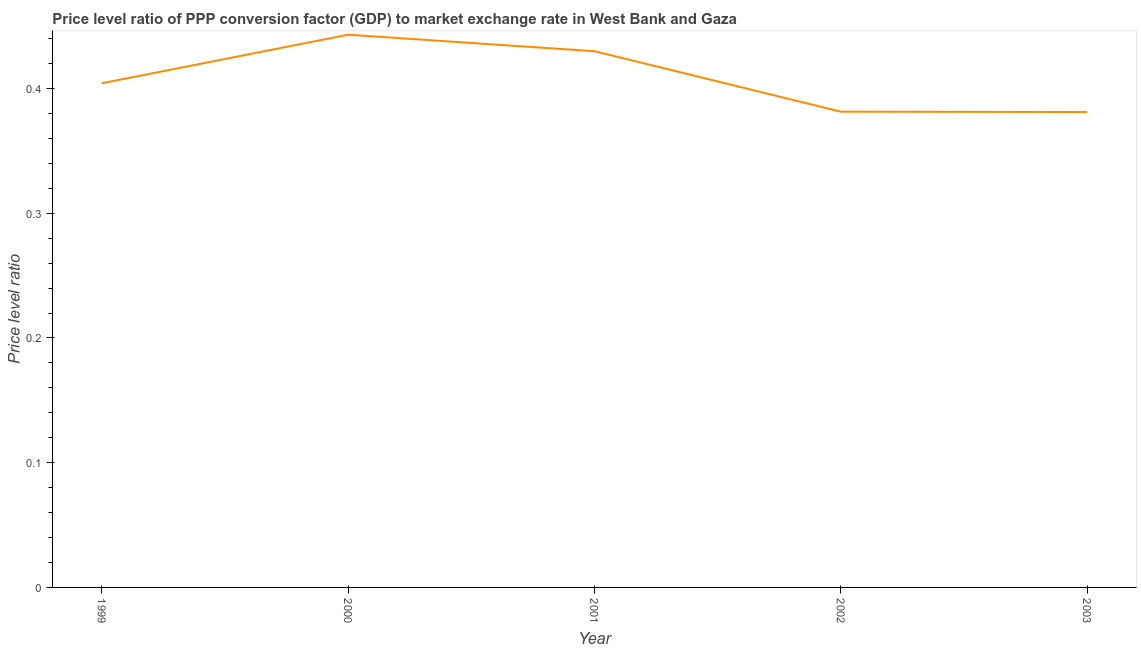What is the price level ratio in 2001?
Make the answer very short. 0.43. Across all years, what is the maximum price level ratio?
Provide a short and direct response. 0.44. Across all years, what is the minimum price level ratio?
Offer a terse response. 0.38. What is the sum of the price level ratio?
Offer a terse response. 2.04. What is the difference between the price level ratio in 2000 and 2003?
Give a very brief answer. 0.06. What is the average price level ratio per year?
Provide a succinct answer. 0.41. What is the median price level ratio?
Your response must be concise. 0.4. Do a majority of the years between 1999 and 2002 (inclusive) have price level ratio greater than 0.14 ?
Your response must be concise. Yes. What is the ratio of the price level ratio in 2000 to that in 2001?
Offer a very short reply. 1.03. What is the difference between the highest and the second highest price level ratio?
Provide a short and direct response. 0.01. Is the sum of the price level ratio in 1999 and 2001 greater than the maximum price level ratio across all years?
Make the answer very short. Yes. What is the difference between the highest and the lowest price level ratio?
Give a very brief answer. 0.06. What is the difference between two consecutive major ticks on the Y-axis?
Make the answer very short. 0.1. Are the values on the major ticks of Y-axis written in scientific E-notation?
Provide a succinct answer. No. What is the title of the graph?
Your response must be concise. Price level ratio of PPP conversion factor (GDP) to market exchange rate in West Bank and Gaza. What is the label or title of the Y-axis?
Offer a terse response. Price level ratio. What is the Price level ratio of 1999?
Your answer should be compact. 0.4. What is the Price level ratio of 2000?
Keep it short and to the point. 0.44. What is the Price level ratio in 2001?
Your answer should be very brief. 0.43. What is the Price level ratio in 2002?
Ensure brevity in your answer.  0.38. What is the Price level ratio in 2003?
Your response must be concise. 0.38. What is the difference between the Price level ratio in 1999 and 2000?
Offer a terse response. -0.04. What is the difference between the Price level ratio in 1999 and 2001?
Your answer should be very brief. -0.03. What is the difference between the Price level ratio in 1999 and 2002?
Your answer should be compact. 0.02. What is the difference between the Price level ratio in 1999 and 2003?
Your response must be concise. 0.02. What is the difference between the Price level ratio in 2000 and 2001?
Offer a very short reply. 0.01. What is the difference between the Price level ratio in 2000 and 2002?
Your answer should be very brief. 0.06. What is the difference between the Price level ratio in 2000 and 2003?
Make the answer very short. 0.06. What is the difference between the Price level ratio in 2001 and 2002?
Your answer should be compact. 0.05. What is the difference between the Price level ratio in 2001 and 2003?
Your answer should be very brief. 0.05. What is the ratio of the Price level ratio in 1999 to that in 2000?
Your response must be concise. 0.91. What is the ratio of the Price level ratio in 1999 to that in 2001?
Your answer should be compact. 0.94. What is the ratio of the Price level ratio in 1999 to that in 2002?
Offer a terse response. 1.06. What is the ratio of the Price level ratio in 1999 to that in 2003?
Keep it short and to the point. 1.06. What is the ratio of the Price level ratio in 2000 to that in 2001?
Give a very brief answer. 1.03. What is the ratio of the Price level ratio in 2000 to that in 2002?
Offer a terse response. 1.16. What is the ratio of the Price level ratio in 2000 to that in 2003?
Your response must be concise. 1.16. What is the ratio of the Price level ratio in 2001 to that in 2002?
Ensure brevity in your answer.  1.13. What is the ratio of the Price level ratio in 2001 to that in 2003?
Provide a short and direct response. 1.13. What is the ratio of the Price level ratio in 2002 to that in 2003?
Make the answer very short. 1. 